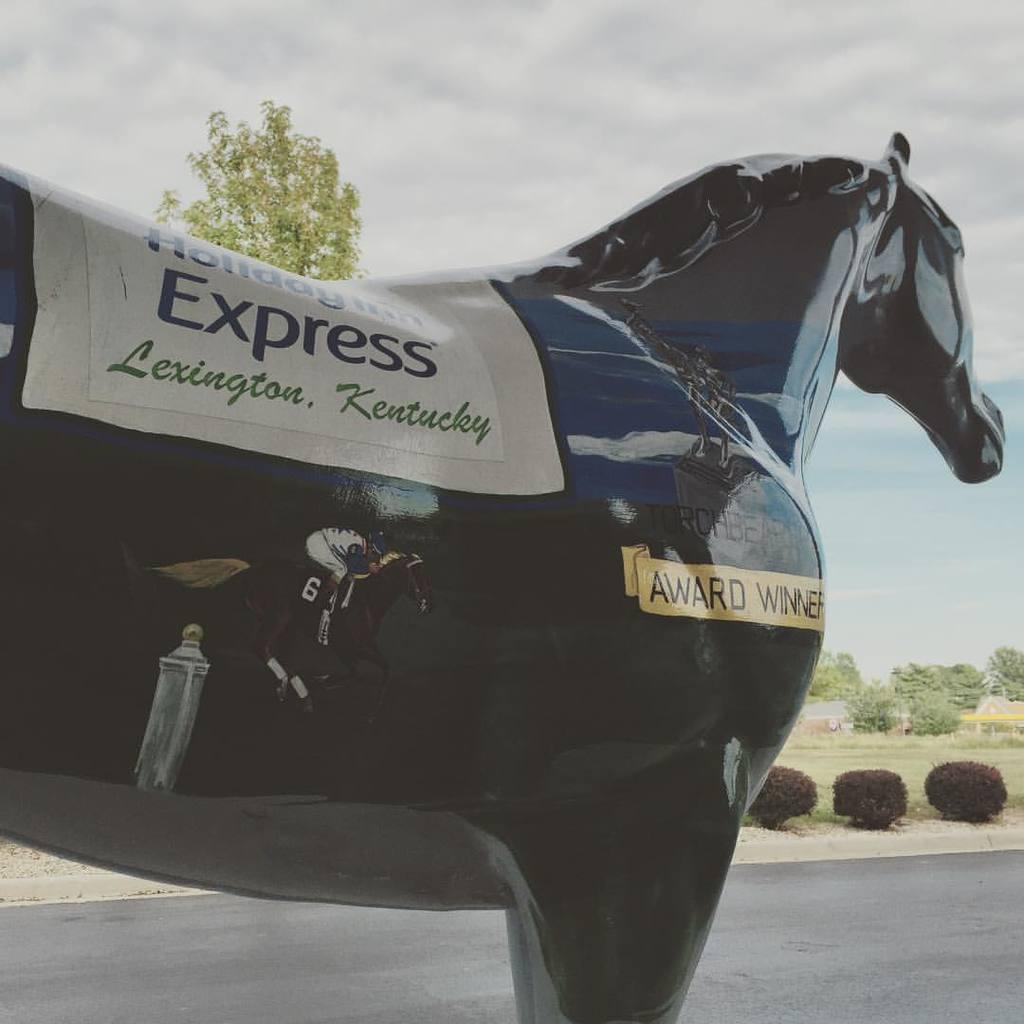What is the main subject in the center of the image? There is a statue in the center of the image. What type of vegetation is on the right side of the image? There are bushes and trees on the right side of the image. What type of ground cover is on the right side of the image? There is grass on the right side of the image. What type of pathway is on the right side of the image? There is a road on the right side of the image. What is visible at the top of the image? The sky is visible at the top of the image. What type of jail can be seen in the image? There is no jail present in the image. What type of stew is being served in the image? There is no stew present in the image. 